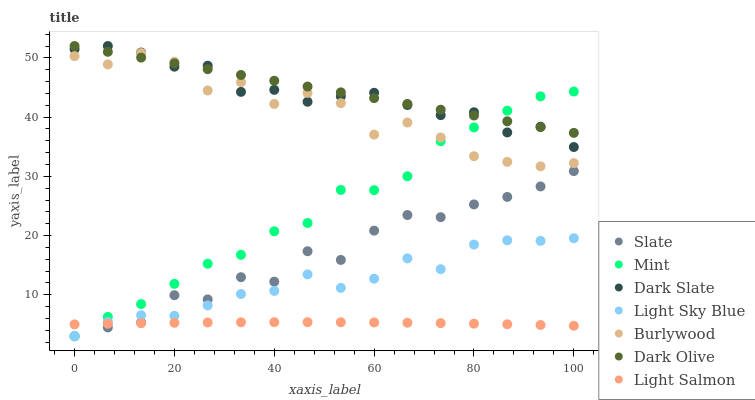Does Light Salmon have the minimum area under the curve?
Answer yes or no. Yes. Does Dark Olive have the maximum area under the curve?
Answer yes or no. Yes. Does Burlywood have the minimum area under the curve?
Answer yes or no. No. Does Burlywood have the maximum area under the curve?
Answer yes or no. No. Is Dark Olive the smoothest?
Answer yes or no. Yes. Is Burlywood the roughest?
Answer yes or no. Yes. Is Slate the smoothest?
Answer yes or no. No. Is Slate the roughest?
Answer yes or no. No. Does Slate have the lowest value?
Answer yes or no. Yes. Does Burlywood have the lowest value?
Answer yes or no. No. Does Dark Slate have the highest value?
Answer yes or no. Yes. Does Burlywood have the highest value?
Answer yes or no. No. Is Light Salmon less than Dark Olive?
Answer yes or no. Yes. Is Dark Olive greater than Slate?
Answer yes or no. Yes. Does Burlywood intersect Mint?
Answer yes or no. Yes. Is Burlywood less than Mint?
Answer yes or no. No. Is Burlywood greater than Mint?
Answer yes or no. No. Does Light Salmon intersect Dark Olive?
Answer yes or no. No. 